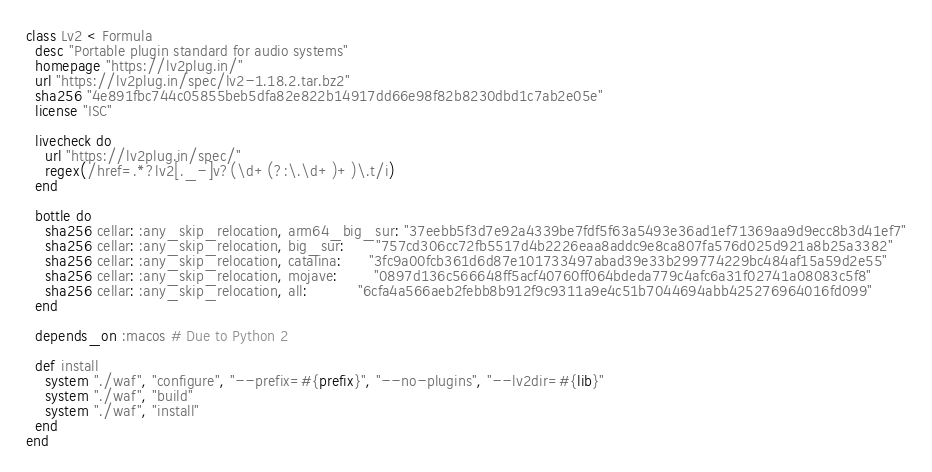Convert code to text. <code><loc_0><loc_0><loc_500><loc_500><_Ruby_>class Lv2 < Formula
  desc "Portable plugin standard for audio systems"
  homepage "https://lv2plug.in/"
  url "https://lv2plug.in/spec/lv2-1.18.2.tar.bz2"
  sha256 "4e891fbc744c05855beb5dfa82e822b14917dd66e98f82b8230dbd1c7ab2e05e"
  license "ISC"

  livecheck do
    url "https://lv2plug.in/spec/"
    regex(/href=.*?lv2[._-]v?(\d+(?:\.\d+)+)\.t/i)
  end

  bottle do
    sha256 cellar: :any_skip_relocation, arm64_big_sur: "37eebb5f3d7e92a4339be7fdf5f63a5493e36ad1ef71369aa9d9ecc8b3d41ef7"
    sha256 cellar: :any_skip_relocation, big_sur:       "757cd306cc72fb5517d4b2226eaa8addc9e8ca807fa576d025d921a8b25a3382"
    sha256 cellar: :any_skip_relocation, catalina:      "3fc9a00fcb361d6d87e101733497abad39e33b299774229bc484af15a59d2e55"
    sha256 cellar: :any_skip_relocation, mojave:        "0897d136c566648ff5acf40760ff064bdeda779c4afc6a31f02741a08083c5f8"
    sha256 cellar: :any_skip_relocation, all:           "6cfa4a566aeb2febb8b912f9c9311a9e4c51b7044694abb425276964016fd099"
  end

  depends_on :macos # Due to Python 2

  def install
    system "./waf", "configure", "--prefix=#{prefix}", "--no-plugins", "--lv2dir=#{lib}"
    system "./waf", "build"
    system "./waf", "install"
  end
end
</code> 